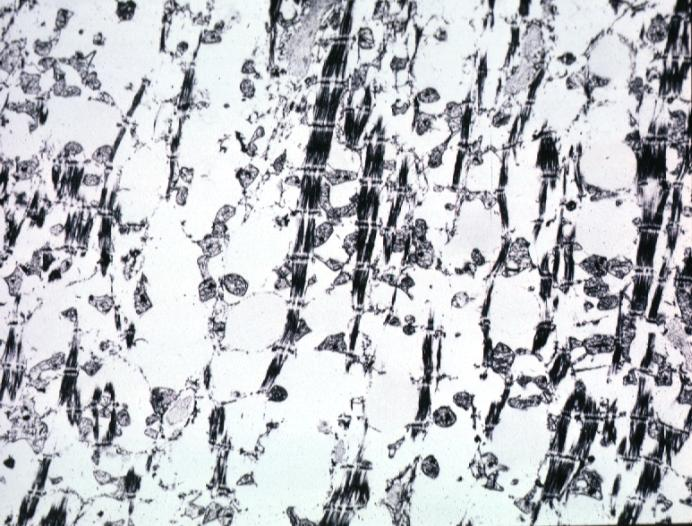s intraductal papillomatosis with apocrine metaplasia present?
Answer the question using a single word or phrase. No 